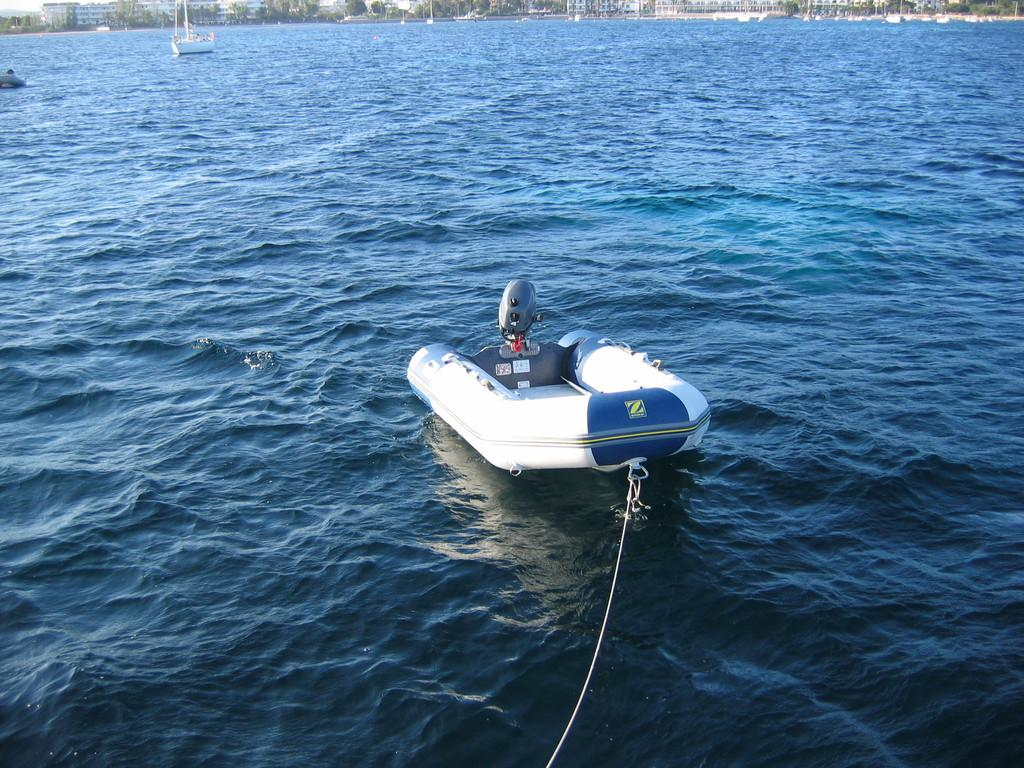<image>
Relay a brief, clear account of the picture shown. A Zodiac inflateable boat with an outboard motor and no one on it. 